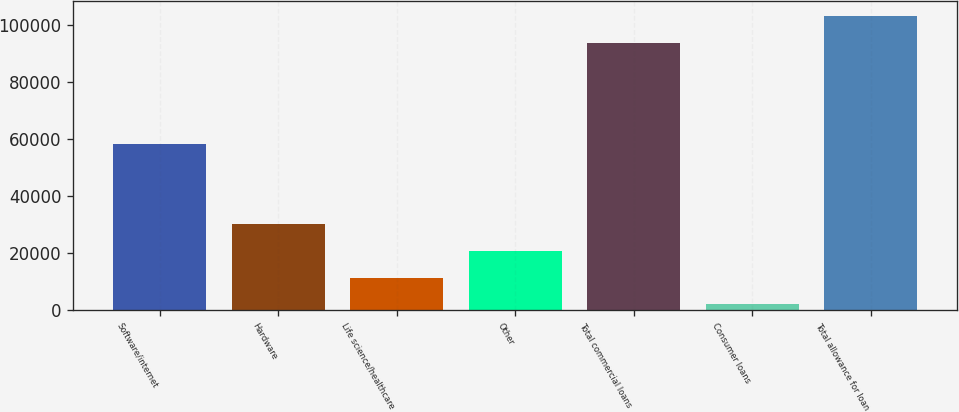<chart> <loc_0><loc_0><loc_500><loc_500><bar_chart><fcel>Software/internet<fcel>Hardware<fcel>Life science/healthcare<fcel>Other<fcel>Total commercial loans<fcel>Consumer loans<fcel>Total allowance for loan<nl><fcel>58350<fcel>29977.5<fcel>11200.5<fcel>20589<fcel>93885<fcel>1812<fcel>103274<nl></chart> 